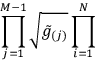Convert formula to latex. <formula><loc_0><loc_0><loc_500><loc_500>\prod _ { j = 1 } ^ { M - 1 } \sqrt { \tilde { g } _ { ( j ) } } \prod _ { i = 1 } ^ { N }</formula> 